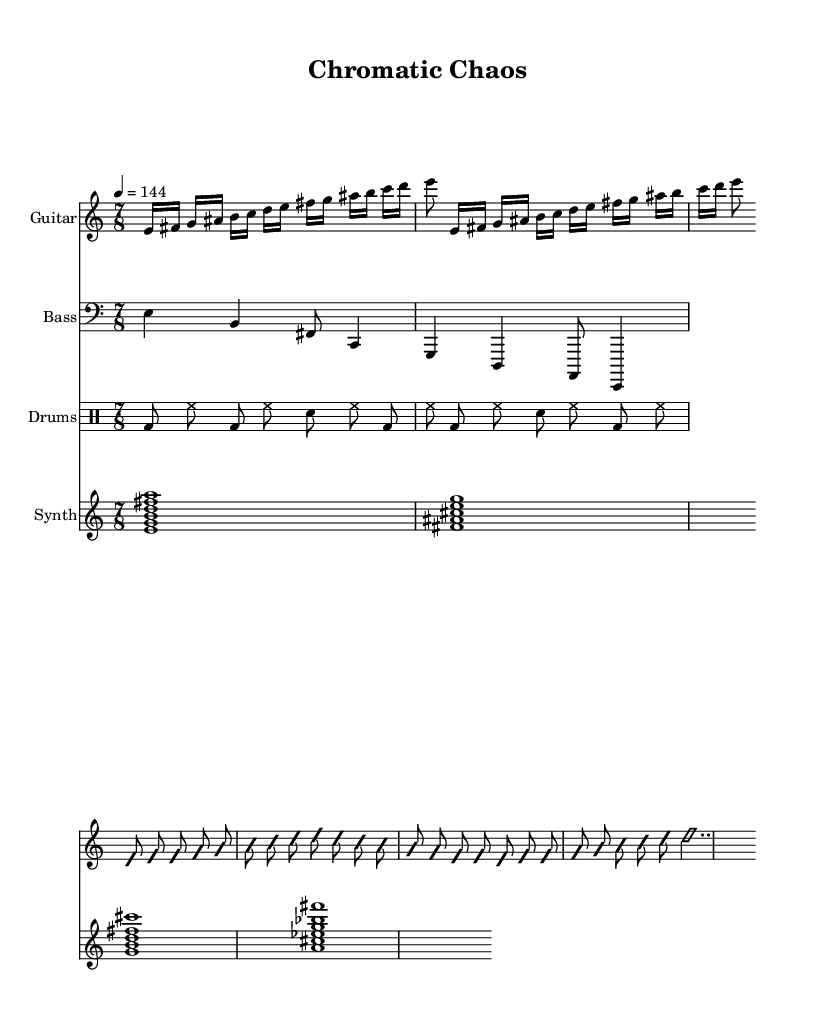What is the time signature of this music? The time signature is indicated at the beginning of the score, displayed as 7/8. This means there are 7 beats per measure, and the eighth note gets one beat.
Answer: 7/8 What is the tempo marking in the sheet music? The tempo marking is specified above the staff as 4 equals 144, indicating that there are 144 quarter note beats per minute, which is a relatively fast tempo.
Answer: 144 How many measures does the guitar riff repeat? The guitar riff is specified with the notation "repeat unfold 2," meaning it is repeated two times.
Answer: 2 What kind of chord is used for the synth pad on the first measure? The synth pad chord in the first measure is written as e minor 11, which is a chord built on the notes E, G, B, D, and F#.
Answer: e minor 11 What is the note value of the last note in the guitar solo? The last note in the guitar solo is marked as e2.., which indicates it is a whole note, lasting for four beats in the context of the music.
Answer: Whole note What is the main rhythmic feature of the drum pattern? The drum pattern features a consistent use of bass drum and hi-hat with an eighth note subdivision, creating a driving rhythm typical of metal music.
Answer: Eighth note subdivision What does the term "improvisationOn" indicate in the context of the guitar solo? The term "improvisationOn" indicates that the guitarist is free to create spontaneous melodic lines and variations, typical of jazz-influenced styles within metal.
Answer: Improvisation 